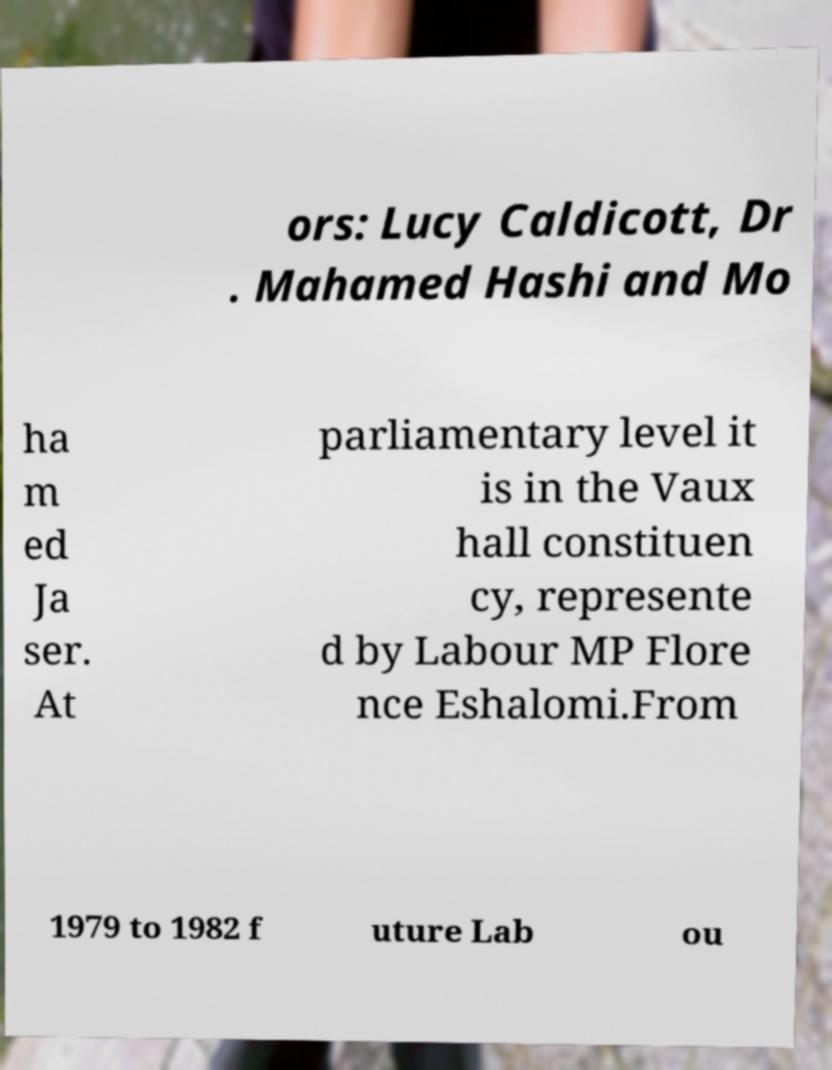I need the written content from this picture converted into text. Can you do that? ors: Lucy Caldicott, Dr . Mahamed Hashi and Mo ha m ed Ja ser. At parliamentary level it is in the Vaux hall constituen cy, represente d by Labour MP Flore nce Eshalomi.From 1979 to 1982 f uture Lab ou 